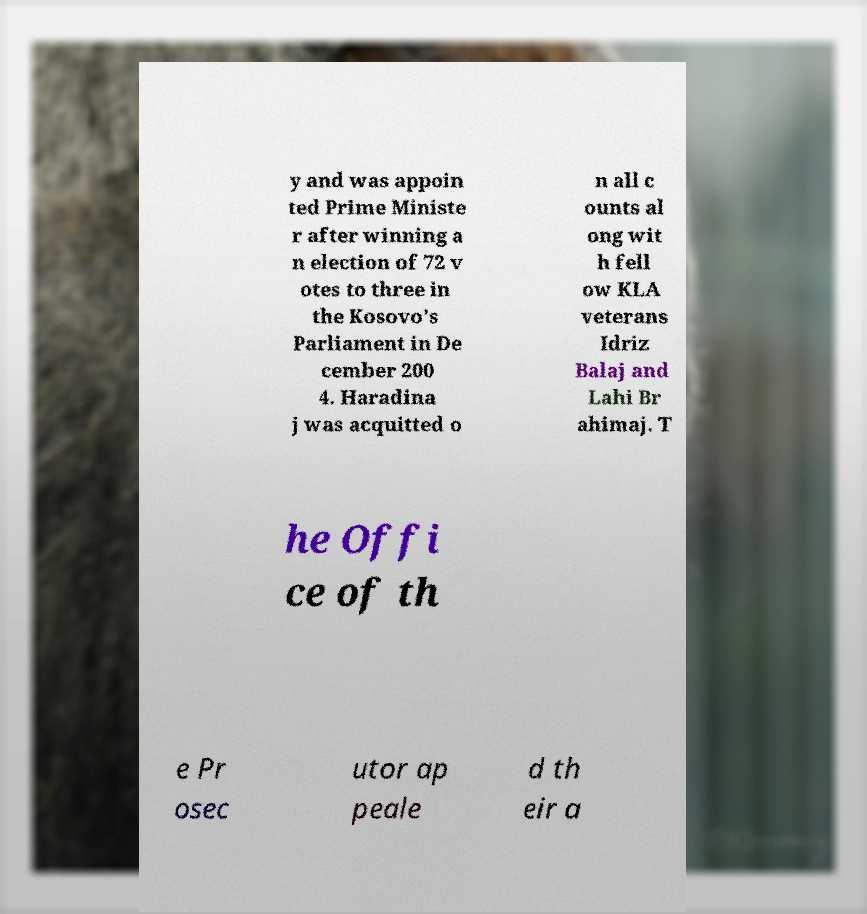Could you assist in decoding the text presented in this image and type it out clearly? y and was appoin ted Prime Ministe r after winning a n election of 72 v otes to three in the Kosovo's Parliament in De cember 200 4. Haradina j was acquitted o n all c ounts al ong wit h fell ow KLA veterans Idriz Balaj and Lahi Br ahimaj. T he Offi ce of th e Pr osec utor ap peale d th eir a 